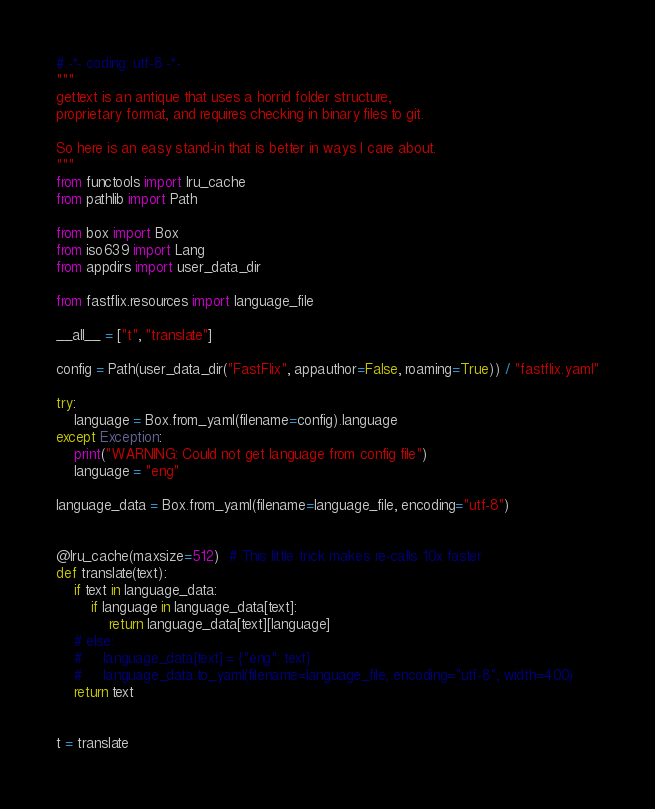<code> <loc_0><loc_0><loc_500><loc_500><_Python_># -*- coding: utf-8 -*-
"""
gettext is an antique that uses a horrid folder structure,
proprietary format, and requires checking in binary files to git.

So here is an easy stand-in that is better in ways I care about.
"""
from functools import lru_cache
from pathlib import Path

from box import Box
from iso639 import Lang
from appdirs import user_data_dir

from fastflix.resources import language_file

__all__ = ["t", "translate"]

config = Path(user_data_dir("FastFlix", appauthor=False, roaming=True)) / "fastflix.yaml"

try:
    language = Box.from_yaml(filename=config).language
except Exception:
    print("WARNING: Could not get language from config file")
    language = "eng"

language_data = Box.from_yaml(filename=language_file, encoding="utf-8")


@lru_cache(maxsize=512)  # This little trick makes re-calls 10x faster
def translate(text):
    if text in language_data:
        if language in language_data[text]:
            return language_data[text][language]
    # else:
    #     language_data[text] = {"eng": text}
    #     language_data.to_yaml(filename=language_file, encoding="utf-8", width=400)
    return text


t = translate
</code> 